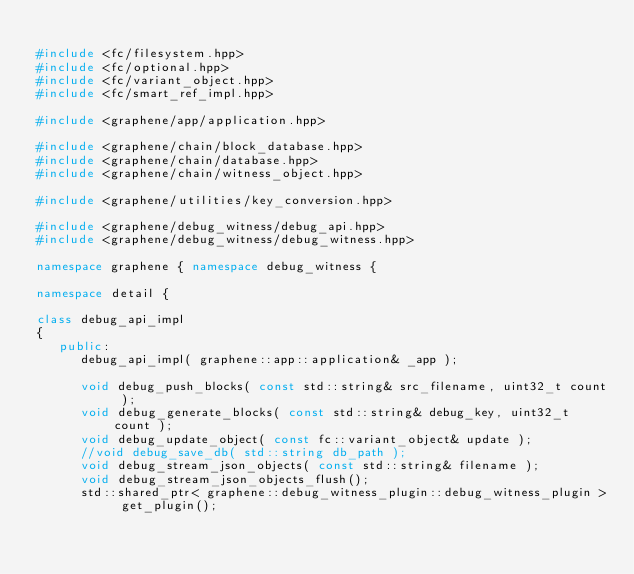<code> <loc_0><loc_0><loc_500><loc_500><_C++_>
#include <fc/filesystem.hpp>
#include <fc/optional.hpp>
#include <fc/variant_object.hpp>
#include <fc/smart_ref_impl.hpp>

#include <graphene/app/application.hpp>

#include <graphene/chain/block_database.hpp>
#include <graphene/chain/database.hpp>
#include <graphene/chain/witness_object.hpp>

#include <graphene/utilities/key_conversion.hpp>

#include <graphene/debug_witness/debug_api.hpp>
#include <graphene/debug_witness/debug_witness.hpp>

namespace graphene { namespace debug_witness {

namespace detail {

class debug_api_impl
{
   public:
      debug_api_impl( graphene::app::application& _app );

      void debug_push_blocks( const std::string& src_filename, uint32_t count );
      void debug_generate_blocks( const std::string& debug_key, uint32_t count );
      void debug_update_object( const fc::variant_object& update );
      //void debug_save_db( std::string db_path );
      void debug_stream_json_objects( const std::string& filename );
      void debug_stream_json_objects_flush();
      std::shared_ptr< graphene::debug_witness_plugin::debug_witness_plugin > get_plugin();
</code> 